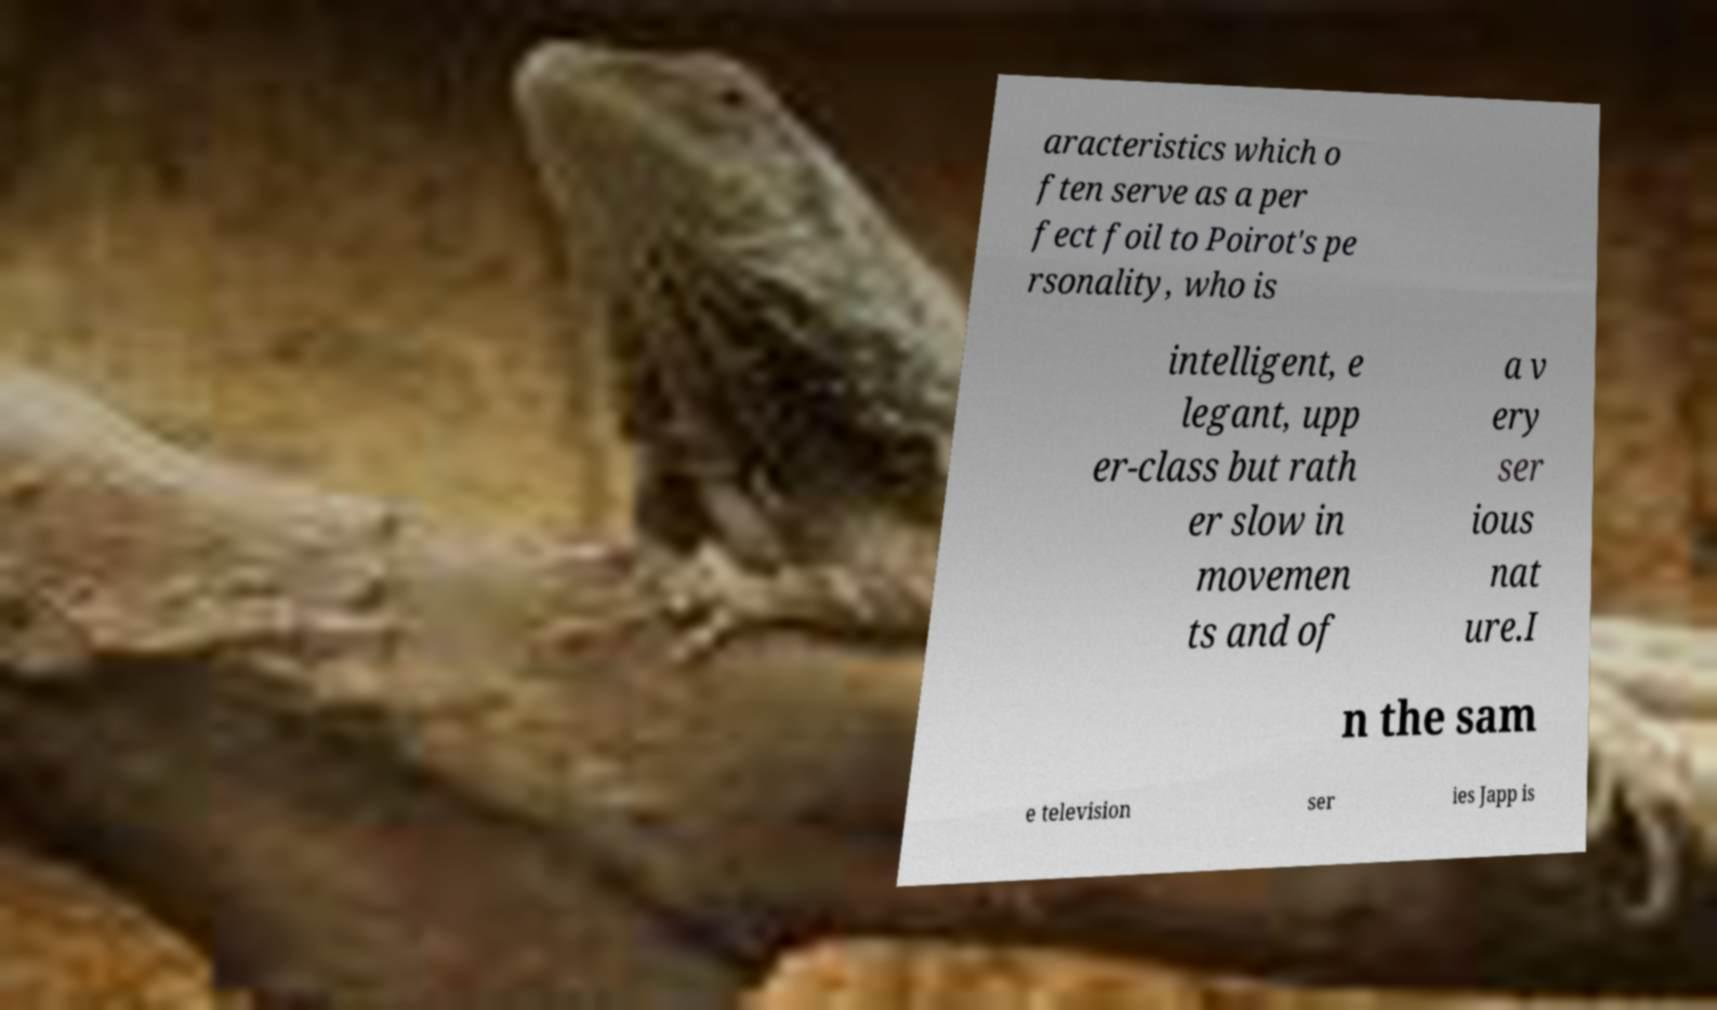Can you read and provide the text displayed in the image?This photo seems to have some interesting text. Can you extract and type it out for me? aracteristics which o ften serve as a per fect foil to Poirot's pe rsonality, who is intelligent, e legant, upp er-class but rath er slow in movemen ts and of a v ery ser ious nat ure.I n the sam e television ser ies Japp is 